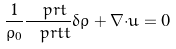<formula> <loc_0><loc_0><loc_500><loc_500>\frac { 1 } { \rho _ { 0 } } \frac { \ p r t } { \ p r t t } { \delta \rho } + { \nabla } { \cdot } { u } = 0</formula> 